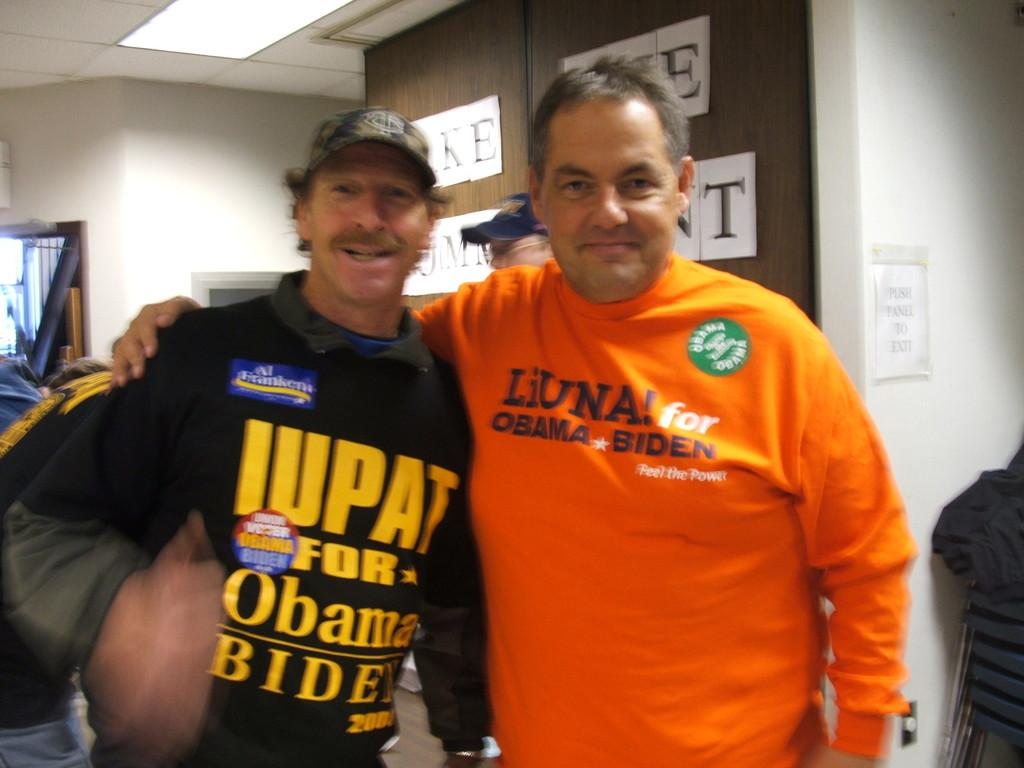<image>
Share a concise interpretation of the image provided. Two men wearing shirts that support Obama and Biden 